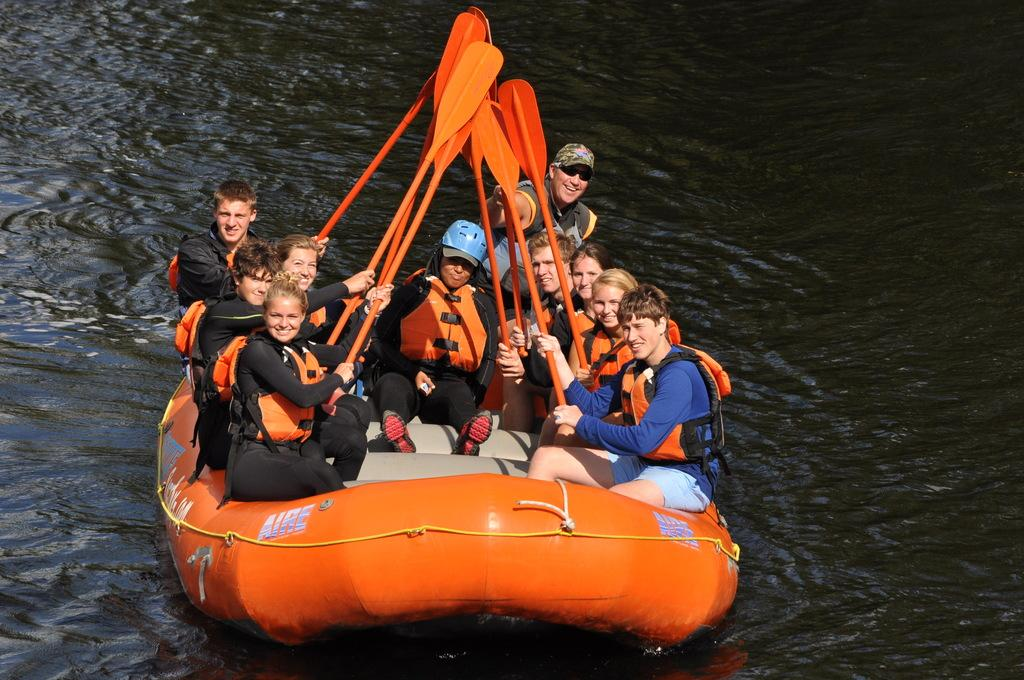What are the people in the image doing? The people in the image are boating in the water. What can be inferred about the time of day when the image was taken? The image is likely taken during the day, as there is sufficient light for the activity to be visible. What type of curtain is hanging in the boat in the image? There is no curtain present in the image, as it features a group of people boating in the water. 